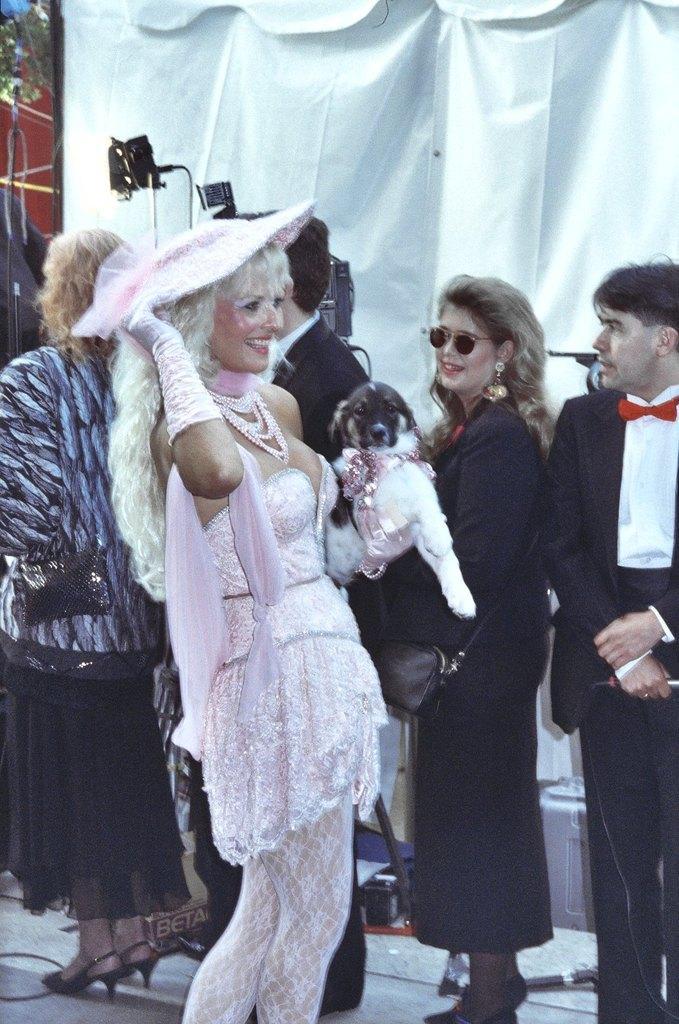Could you give a brief overview of what you see in this image? In this image I can see the group of people with different color dresses. I can see one person is holding the dog which is in white and black color and another person is wearing the goggles. In the background I can see the camera and the white color cloth. 